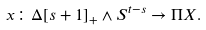<formula> <loc_0><loc_0><loc_500><loc_500>x \colon \Delta [ s + 1 ] _ { + } \wedge S ^ { t - s } \rightarrow \Pi X .</formula> 